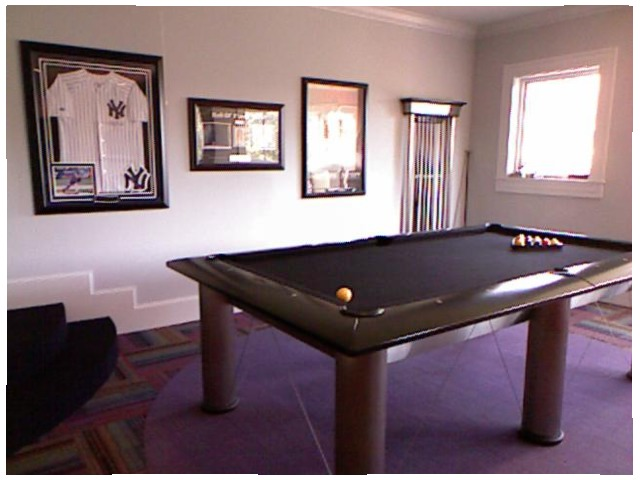<image>
Can you confirm if the table is under the photo frame? No. The table is not positioned under the photo frame. The vertical relationship between these objects is different. Is there a ball under the table? No. The ball is not positioned under the table. The vertical relationship between these objects is different. Where is the ball in relation to the court? Is it on the court? Yes. Looking at the image, I can see the ball is positioned on top of the court, with the court providing support. Where is the frame in relation to the wall? Is it on the wall? Yes. Looking at the image, I can see the frame is positioned on top of the wall, with the wall providing support. Is the shirt above the frame? No. The shirt is not positioned above the frame. The vertical arrangement shows a different relationship. Is the shirt in the frame? Yes. The shirt is contained within or inside the frame, showing a containment relationship. 